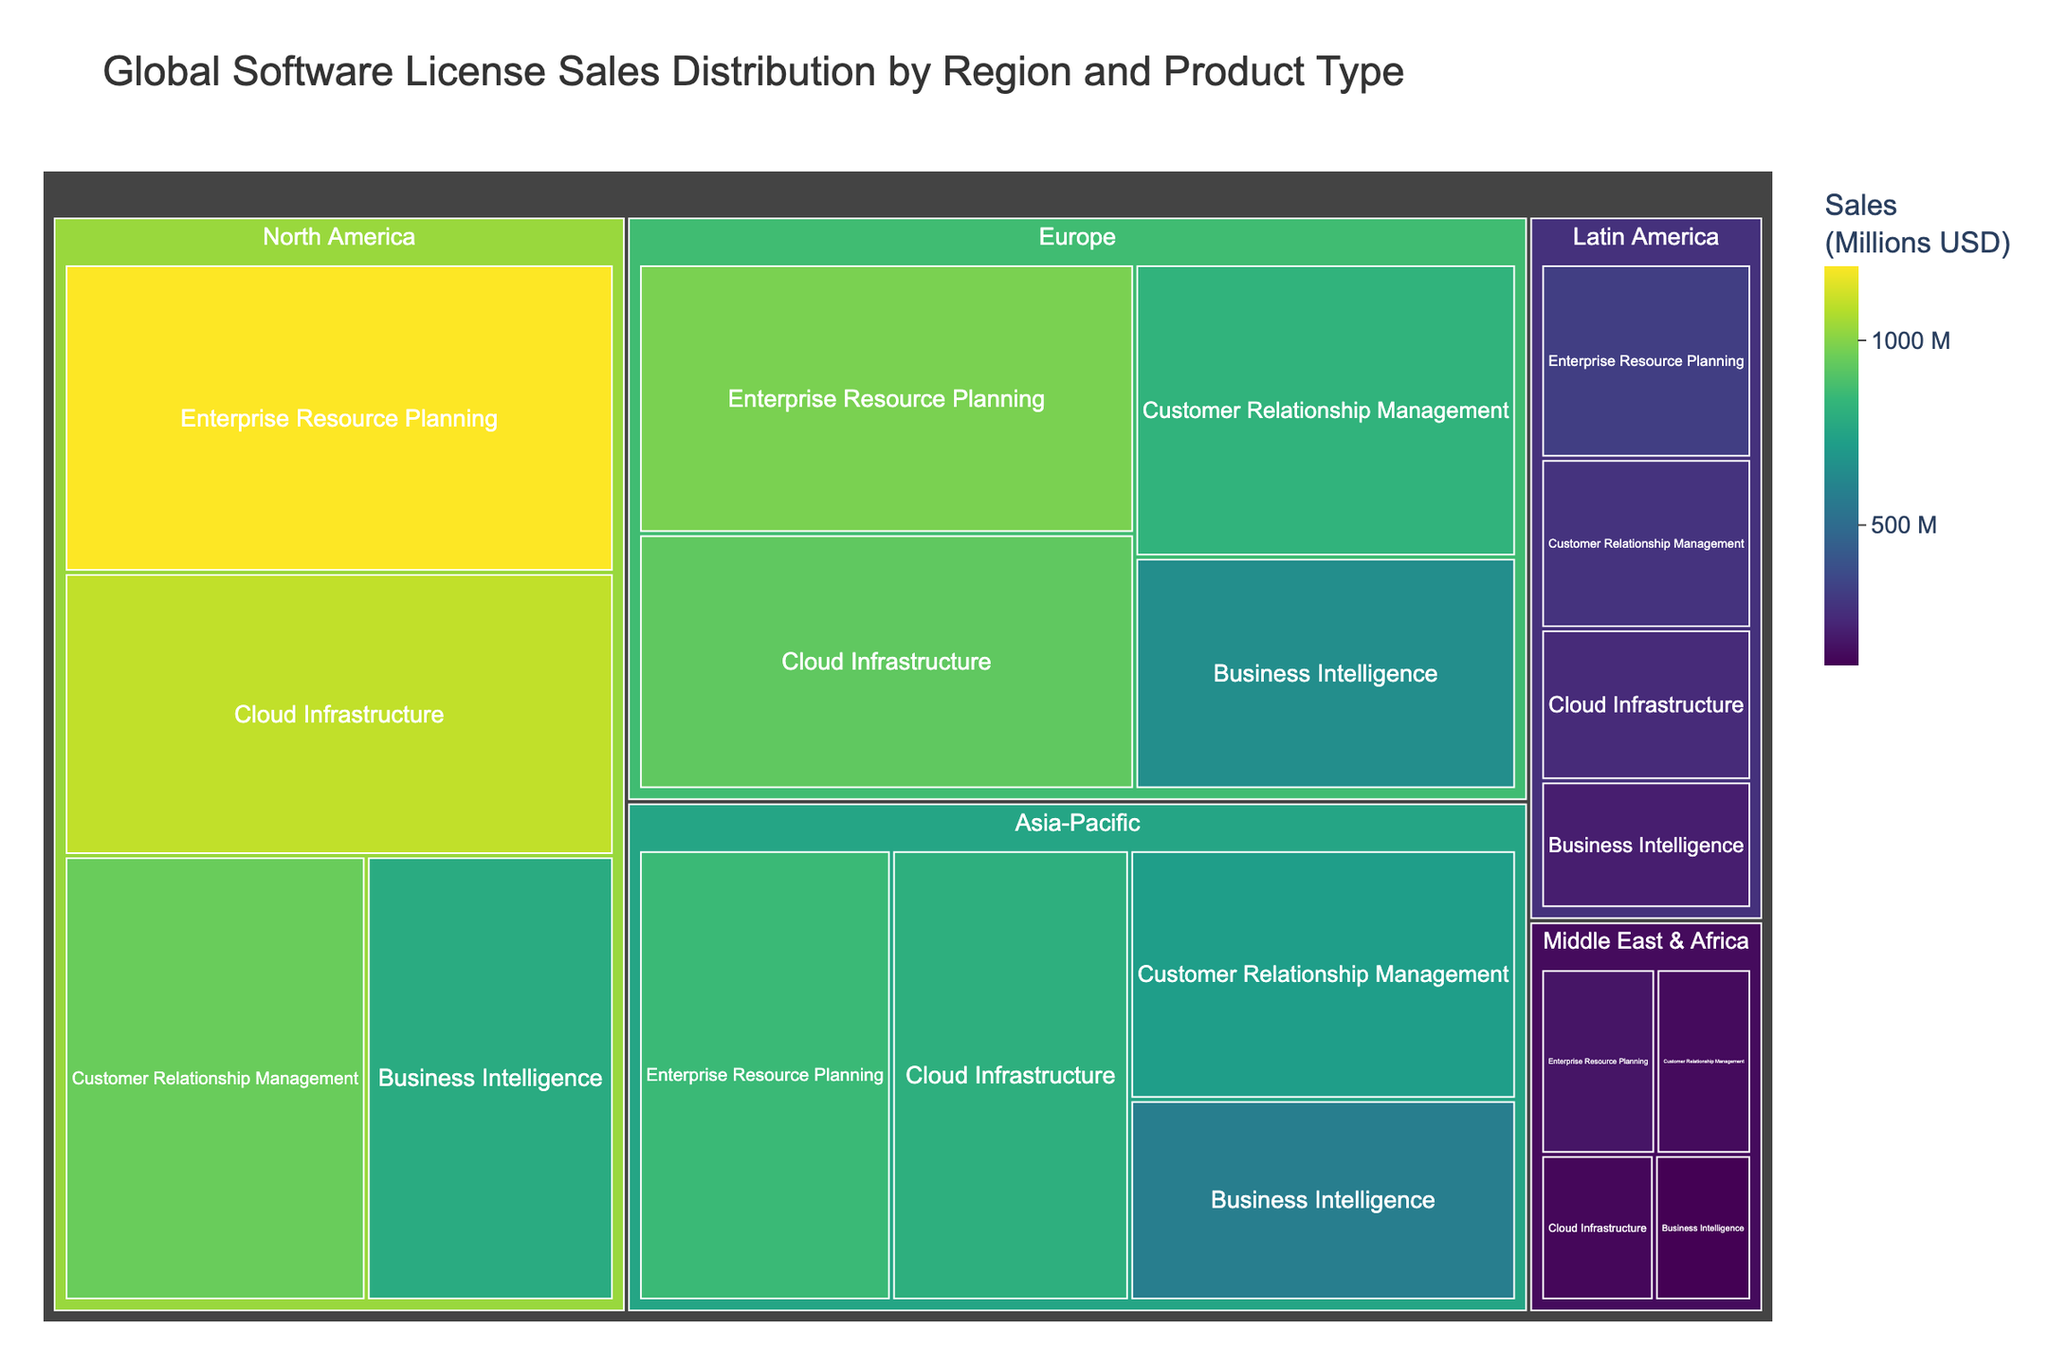What is the title of the Treemap? The title is usually displayed at the top of the Treemap and describes the main focus of the chart. In this case, the title is given as "Global Software License Sales Distribution by Region and Product Type".
Answer: Global Software License Sales Distribution by Region and Product Type Which region has the highest total sales? From the Treemap, the region with the largest area and highest value on the color scale will indicate the highest total sales.
Answer: North America What is the sales figure for Enterprise Resource Planning in Europe? Hover over the block corresponding to Enterprise Resource Planning in Europe on the Treemap, which will show the sales figure.
Answer: $980 million Which product type has the lowest sales in Latin America? Examine the size and color intensity of each product type block within the Latin America region and find the smallest and least intense colored block.
Answer: Business Intelligence How do the Cloud Infrastructure sales in North America compare to those in Asia-Pacific? Identify the sales figures for Cloud Infrastructure in both North America and Asia-Pacific by looking at the respective blocks and compare the figures ($1100 million vs. $800 million).
Answer: North America has higher sales by $300 million What is the total sales for Customer Relationship Management across all regions? Sum the sales figures for Customer Relationship Management in all the regions: North America ($950 million), Europe ($820 million), Asia-Pacific ($720 million), Latin America ($280 million), and Middle East & Africa ($150 million).
Answer: $2920 million Which product type in the Asia-Pacific region has almost the same sales as Business Intelligence in North America? Compare the sales figures of product types in the Asia-Pacific region with Business Intelligence in North America and find the nearest one.
Answer: Enterprise Resource Planning in Asia-Pacific ($850 million) is close to Business Intelligence in North America ($780 million) What's the average sales figure for Enterprise Resource Planning across all regions? Sum the sales figures for Enterprise Resource Planning in all regions and divide by the number of regions (North America: $1200 million, Europe: $980 million, Asia-Pacific: $850 million, Latin America: $320 million, Middle East & Africa: $180 million). Average = ($1200 + $980 + $850 + $320 + $180) / 5.
Answer: $706 million 